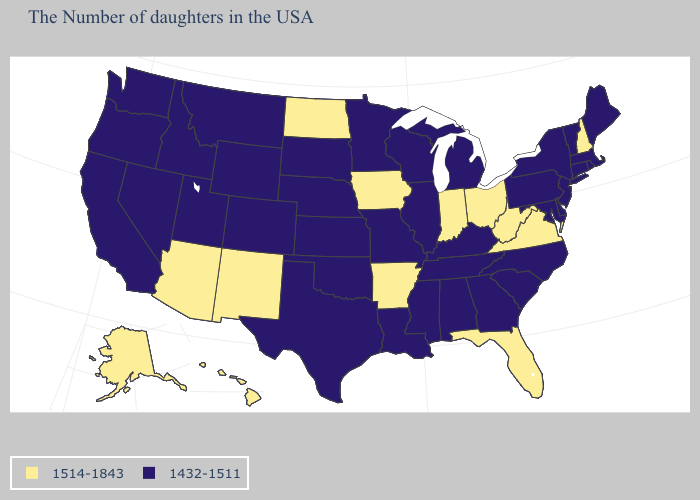What is the highest value in the West ?
Short answer required. 1514-1843. Name the states that have a value in the range 1514-1843?
Give a very brief answer. New Hampshire, Virginia, West Virginia, Ohio, Florida, Indiana, Arkansas, Iowa, North Dakota, New Mexico, Arizona, Alaska, Hawaii. Which states have the highest value in the USA?
Concise answer only. New Hampshire, Virginia, West Virginia, Ohio, Florida, Indiana, Arkansas, Iowa, North Dakota, New Mexico, Arizona, Alaska, Hawaii. How many symbols are there in the legend?
Answer briefly. 2. What is the value of Oklahoma?
Be succinct. 1432-1511. Which states have the lowest value in the MidWest?
Give a very brief answer. Michigan, Wisconsin, Illinois, Missouri, Minnesota, Kansas, Nebraska, South Dakota. What is the value of New York?
Answer briefly. 1432-1511. Does Oregon have the highest value in the USA?
Give a very brief answer. No. Does the map have missing data?
Concise answer only. No. Does Alabama have a higher value than Michigan?
Keep it brief. No. What is the highest value in the USA?
Short answer required. 1514-1843. Which states have the lowest value in the USA?
Concise answer only. Maine, Massachusetts, Rhode Island, Vermont, Connecticut, New York, New Jersey, Delaware, Maryland, Pennsylvania, North Carolina, South Carolina, Georgia, Michigan, Kentucky, Alabama, Tennessee, Wisconsin, Illinois, Mississippi, Louisiana, Missouri, Minnesota, Kansas, Nebraska, Oklahoma, Texas, South Dakota, Wyoming, Colorado, Utah, Montana, Idaho, Nevada, California, Washington, Oregon. Name the states that have a value in the range 1514-1843?
Write a very short answer. New Hampshire, Virginia, West Virginia, Ohio, Florida, Indiana, Arkansas, Iowa, North Dakota, New Mexico, Arizona, Alaska, Hawaii. Name the states that have a value in the range 1514-1843?
Concise answer only. New Hampshire, Virginia, West Virginia, Ohio, Florida, Indiana, Arkansas, Iowa, North Dakota, New Mexico, Arizona, Alaska, Hawaii. What is the lowest value in states that border Alabama?
Short answer required. 1432-1511. 